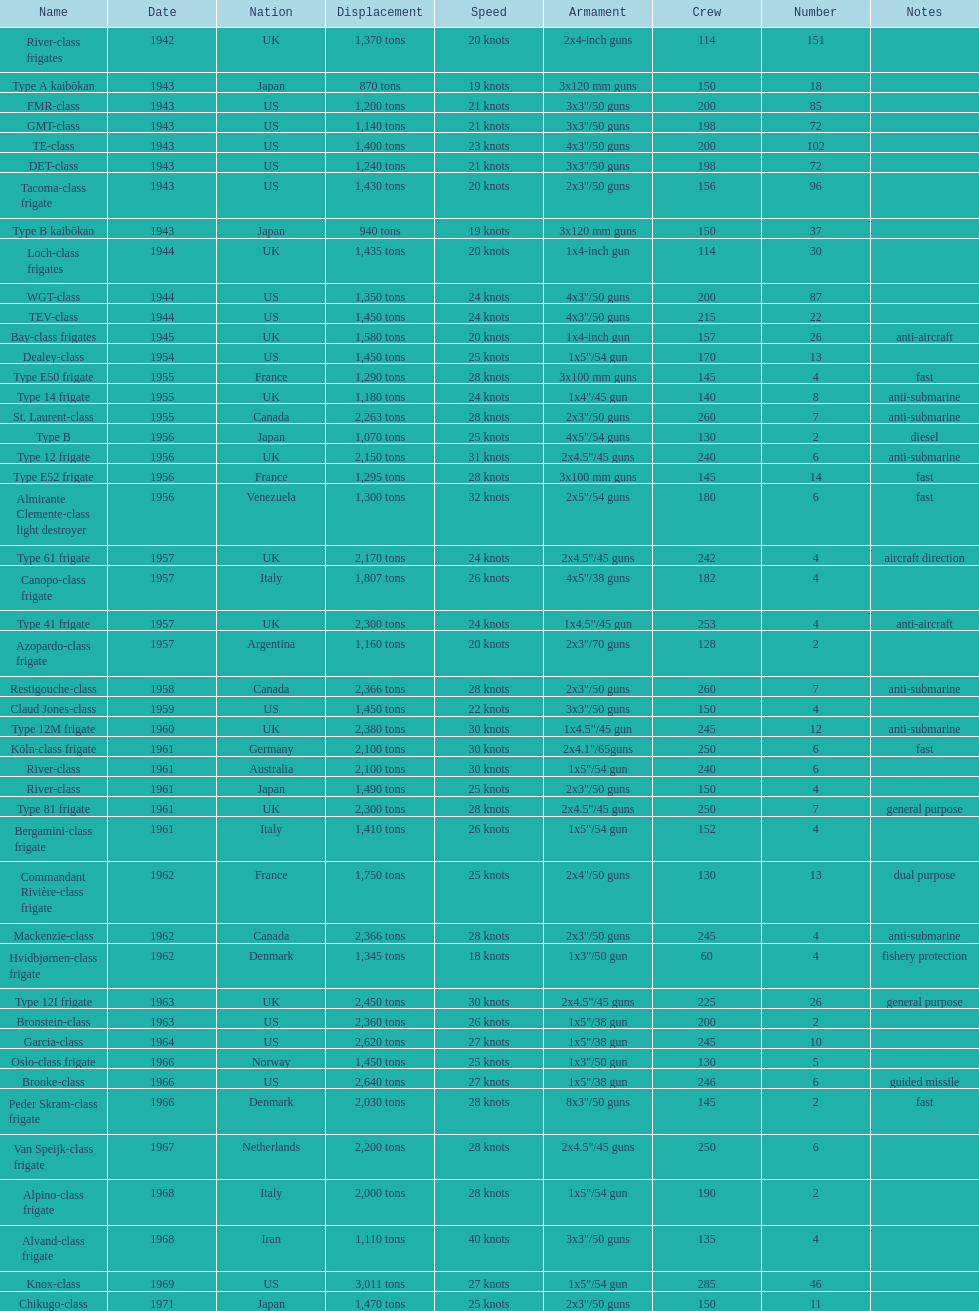Which name holds the biggest displacement? Knox-class. 